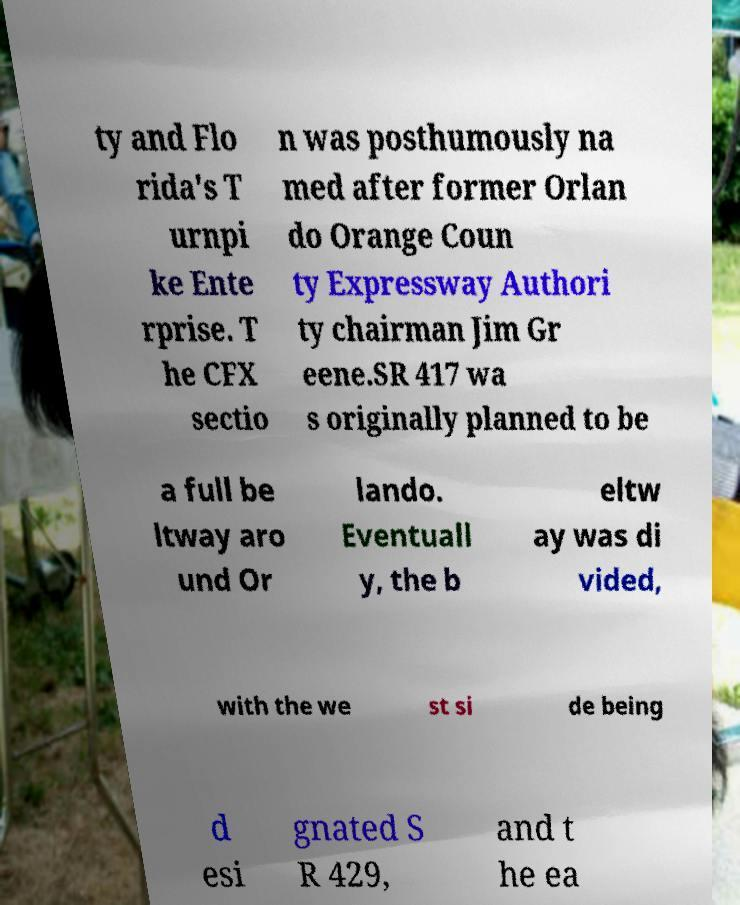Please identify and transcribe the text found in this image. ty and Flo rida's T urnpi ke Ente rprise. T he CFX sectio n was posthumously na med after former Orlan do Orange Coun ty Expressway Authori ty chairman Jim Gr eene.SR 417 wa s originally planned to be a full be ltway aro und Or lando. Eventuall y, the b eltw ay was di vided, with the we st si de being d esi gnated S R 429, and t he ea 